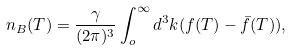Convert formula to latex. <formula><loc_0><loc_0><loc_500><loc_500>n _ { B } ( T ) = \frac { \gamma } { ( 2 \pi ) ^ { 3 } } \int ^ { \infty } _ { o } d ^ { 3 } k ( f ( T ) - \bar { f } ( T ) ) ,</formula> 